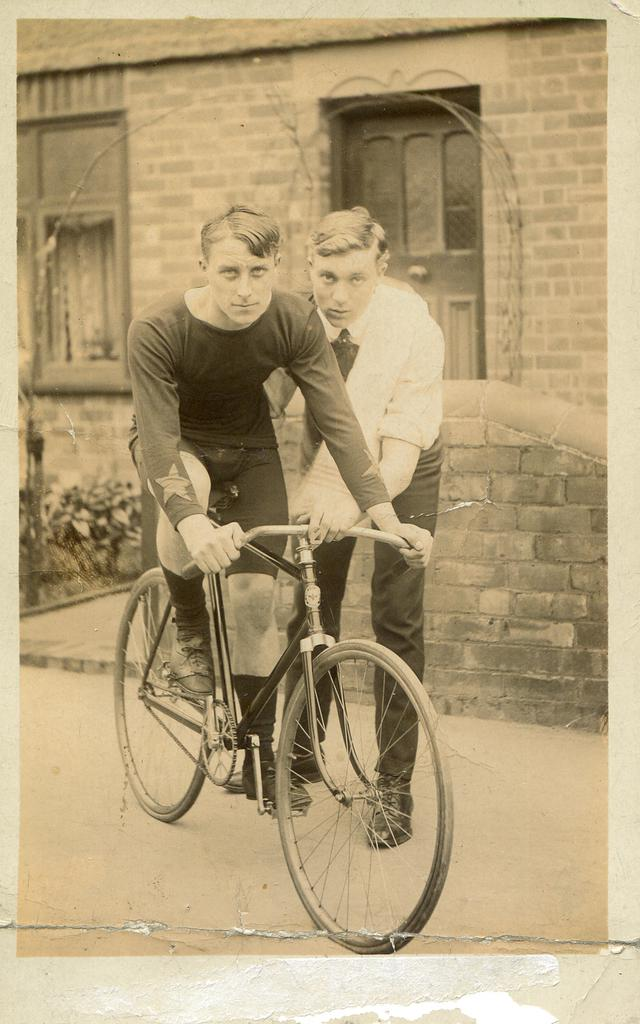How many people are in the image? There are two people in the image. What is one person doing in the image? One person is riding a bicycle. What can be seen in the background of the image? There is a building in the background of the image. What type of cap is the person on the throne wearing in the image? There is no person on a throne or wearing a cap in the image; it only features two people, one of whom is riding a bicycle. 